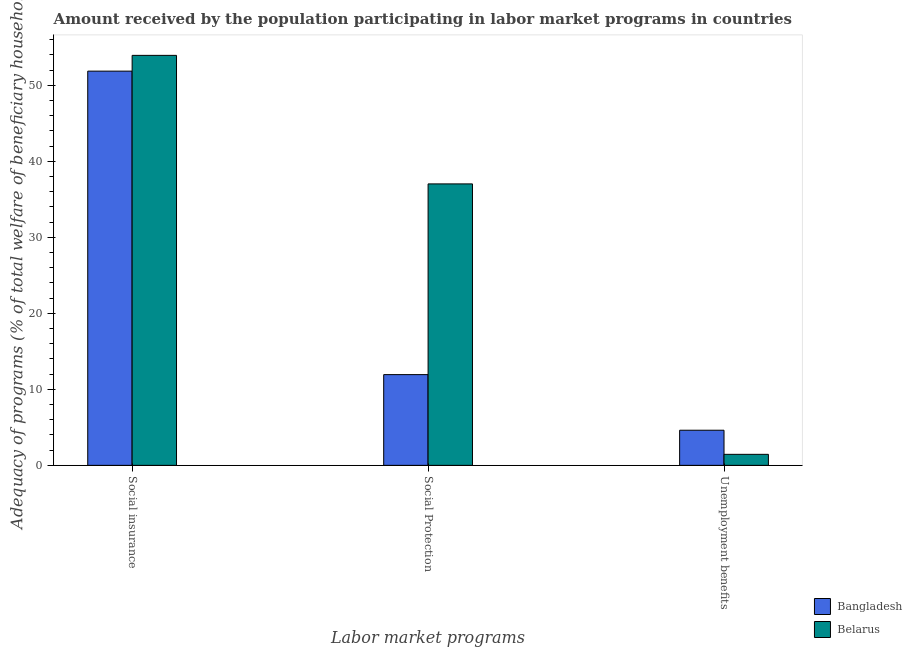How many groups of bars are there?
Your answer should be very brief. 3. Are the number of bars per tick equal to the number of legend labels?
Provide a short and direct response. Yes. How many bars are there on the 2nd tick from the right?
Offer a terse response. 2. What is the label of the 2nd group of bars from the left?
Provide a short and direct response. Social Protection. What is the amount received by the population participating in social insurance programs in Belarus?
Your answer should be compact. 53.93. Across all countries, what is the maximum amount received by the population participating in unemployment benefits programs?
Offer a terse response. 4.62. Across all countries, what is the minimum amount received by the population participating in unemployment benefits programs?
Ensure brevity in your answer.  1.45. In which country was the amount received by the population participating in social insurance programs maximum?
Ensure brevity in your answer.  Belarus. What is the total amount received by the population participating in social protection programs in the graph?
Make the answer very short. 48.96. What is the difference between the amount received by the population participating in social protection programs in Bangladesh and that in Belarus?
Your response must be concise. -25.09. What is the difference between the amount received by the population participating in social insurance programs in Belarus and the amount received by the population participating in unemployment benefits programs in Bangladesh?
Keep it short and to the point. 49.31. What is the average amount received by the population participating in unemployment benefits programs per country?
Provide a short and direct response. 3.04. What is the difference between the amount received by the population participating in social protection programs and amount received by the population participating in social insurance programs in Bangladesh?
Your response must be concise. -39.92. In how many countries, is the amount received by the population participating in social protection programs greater than 12 %?
Make the answer very short. 1. What is the ratio of the amount received by the population participating in unemployment benefits programs in Belarus to that in Bangladesh?
Your answer should be very brief. 0.31. Is the amount received by the population participating in unemployment benefits programs in Belarus less than that in Bangladesh?
Keep it short and to the point. Yes. Is the difference between the amount received by the population participating in social insurance programs in Bangladesh and Belarus greater than the difference between the amount received by the population participating in unemployment benefits programs in Bangladesh and Belarus?
Provide a succinct answer. No. What is the difference between the highest and the second highest amount received by the population participating in unemployment benefits programs?
Give a very brief answer. 3.17. What is the difference between the highest and the lowest amount received by the population participating in unemployment benefits programs?
Ensure brevity in your answer.  3.17. What does the 2nd bar from the left in Social insurance represents?
Provide a succinct answer. Belarus. What does the 1st bar from the right in Social Protection represents?
Offer a very short reply. Belarus. How many bars are there?
Offer a very short reply. 6. Are all the bars in the graph horizontal?
Keep it short and to the point. No. How many countries are there in the graph?
Make the answer very short. 2. Are the values on the major ticks of Y-axis written in scientific E-notation?
Offer a very short reply. No. Where does the legend appear in the graph?
Offer a terse response. Bottom right. How many legend labels are there?
Offer a very short reply. 2. What is the title of the graph?
Your answer should be compact. Amount received by the population participating in labor market programs in countries. What is the label or title of the X-axis?
Give a very brief answer. Labor market programs. What is the label or title of the Y-axis?
Offer a very short reply. Adequacy of programs (% of total welfare of beneficiary households). What is the Adequacy of programs (% of total welfare of beneficiary households) in Bangladesh in Social insurance?
Keep it short and to the point. 51.86. What is the Adequacy of programs (% of total welfare of beneficiary households) in Belarus in Social insurance?
Make the answer very short. 53.93. What is the Adequacy of programs (% of total welfare of beneficiary households) of Bangladesh in Social Protection?
Your response must be concise. 11.94. What is the Adequacy of programs (% of total welfare of beneficiary households) in Belarus in Social Protection?
Your answer should be compact. 37.03. What is the Adequacy of programs (% of total welfare of beneficiary households) in Bangladesh in Unemployment benefits?
Your answer should be very brief. 4.62. What is the Adequacy of programs (% of total welfare of beneficiary households) of Belarus in Unemployment benefits?
Provide a succinct answer. 1.45. Across all Labor market programs, what is the maximum Adequacy of programs (% of total welfare of beneficiary households) in Bangladesh?
Ensure brevity in your answer.  51.86. Across all Labor market programs, what is the maximum Adequacy of programs (% of total welfare of beneficiary households) of Belarus?
Give a very brief answer. 53.93. Across all Labor market programs, what is the minimum Adequacy of programs (% of total welfare of beneficiary households) in Bangladesh?
Ensure brevity in your answer.  4.62. Across all Labor market programs, what is the minimum Adequacy of programs (% of total welfare of beneficiary households) in Belarus?
Offer a very short reply. 1.45. What is the total Adequacy of programs (% of total welfare of beneficiary households) of Bangladesh in the graph?
Provide a succinct answer. 68.42. What is the total Adequacy of programs (% of total welfare of beneficiary households) of Belarus in the graph?
Provide a succinct answer. 92.41. What is the difference between the Adequacy of programs (% of total welfare of beneficiary households) in Bangladesh in Social insurance and that in Social Protection?
Provide a short and direct response. 39.92. What is the difference between the Adequacy of programs (% of total welfare of beneficiary households) in Belarus in Social insurance and that in Social Protection?
Make the answer very short. 16.91. What is the difference between the Adequacy of programs (% of total welfare of beneficiary households) of Bangladesh in Social insurance and that in Unemployment benefits?
Your response must be concise. 47.24. What is the difference between the Adequacy of programs (% of total welfare of beneficiary households) in Belarus in Social insurance and that in Unemployment benefits?
Your answer should be compact. 52.48. What is the difference between the Adequacy of programs (% of total welfare of beneficiary households) of Bangladesh in Social Protection and that in Unemployment benefits?
Your response must be concise. 7.32. What is the difference between the Adequacy of programs (% of total welfare of beneficiary households) in Belarus in Social Protection and that in Unemployment benefits?
Your response must be concise. 35.58. What is the difference between the Adequacy of programs (% of total welfare of beneficiary households) of Bangladesh in Social insurance and the Adequacy of programs (% of total welfare of beneficiary households) of Belarus in Social Protection?
Make the answer very short. 14.84. What is the difference between the Adequacy of programs (% of total welfare of beneficiary households) in Bangladesh in Social insurance and the Adequacy of programs (% of total welfare of beneficiary households) in Belarus in Unemployment benefits?
Keep it short and to the point. 50.41. What is the difference between the Adequacy of programs (% of total welfare of beneficiary households) in Bangladesh in Social Protection and the Adequacy of programs (% of total welfare of beneficiary households) in Belarus in Unemployment benefits?
Provide a short and direct response. 10.49. What is the average Adequacy of programs (% of total welfare of beneficiary households) in Bangladesh per Labor market programs?
Make the answer very short. 22.81. What is the average Adequacy of programs (% of total welfare of beneficiary households) of Belarus per Labor market programs?
Your answer should be very brief. 30.8. What is the difference between the Adequacy of programs (% of total welfare of beneficiary households) in Bangladesh and Adequacy of programs (% of total welfare of beneficiary households) in Belarus in Social insurance?
Offer a terse response. -2.07. What is the difference between the Adequacy of programs (% of total welfare of beneficiary households) in Bangladesh and Adequacy of programs (% of total welfare of beneficiary households) in Belarus in Social Protection?
Provide a short and direct response. -25.09. What is the difference between the Adequacy of programs (% of total welfare of beneficiary households) in Bangladesh and Adequacy of programs (% of total welfare of beneficiary households) in Belarus in Unemployment benefits?
Your answer should be very brief. 3.17. What is the ratio of the Adequacy of programs (% of total welfare of beneficiary households) of Bangladesh in Social insurance to that in Social Protection?
Offer a very short reply. 4.34. What is the ratio of the Adequacy of programs (% of total welfare of beneficiary households) in Belarus in Social insurance to that in Social Protection?
Offer a terse response. 1.46. What is the ratio of the Adequacy of programs (% of total welfare of beneficiary households) of Bangladesh in Social insurance to that in Unemployment benefits?
Your answer should be compact. 11.22. What is the ratio of the Adequacy of programs (% of total welfare of beneficiary households) in Belarus in Social insurance to that in Unemployment benefits?
Offer a very short reply. 37.19. What is the ratio of the Adequacy of programs (% of total welfare of beneficiary households) in Bangladesh in Social Protection to that in Unemployment benefits?
Give a very brief answer. 2.58. What is the ratio of the Adequacy of programs (% of total welfare of beneficiary households) of Belarus in Social Protection to that in Unemployment benefits?
Your answer should be compact. 25.53. What is the difference between the highest and the second highest Adequacy of programs (% of total welfare of beneficiary households) in Bangladesh?
Keep it short and to the point. 39.92. What is the difference between the highest and the second highest Adequacy of programs (% of total welfare of beneficiary households) in Belarus?
Offer a terse response. 16.91. What is the difference between the highest and the lowest Adequacy of programs (% of total welfare of beneficiary households) in Bangladesh?
Your answer should be compact. 47.24. What is the difference between the highest and the lowest Adequacy of programs (% of total welfare of beneficiary households) in Belarus?
Keep it short and to the point. 52.48. 